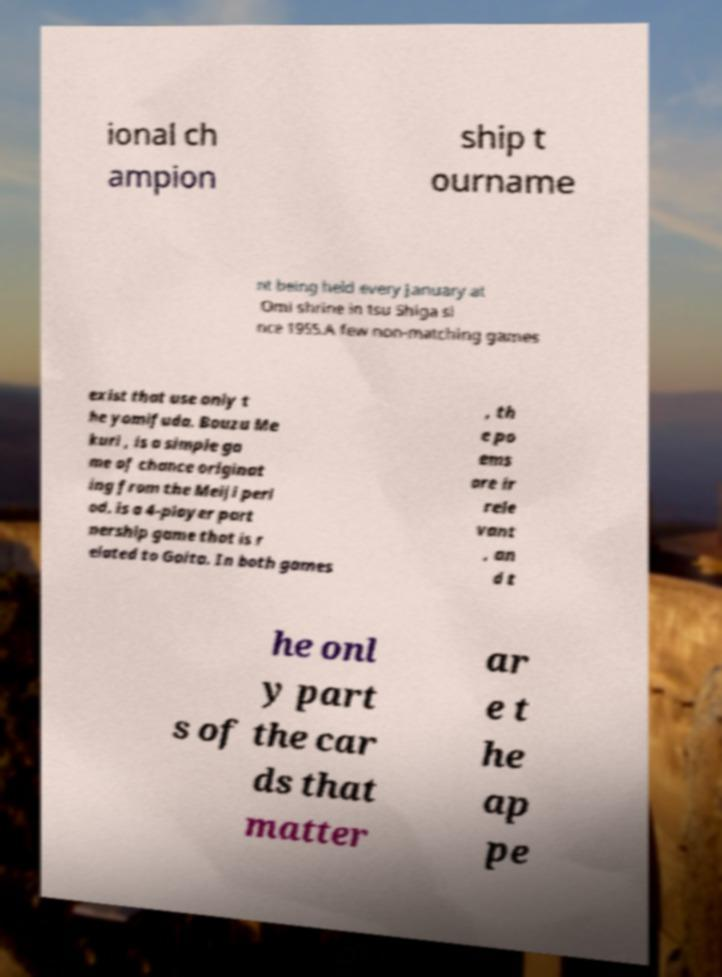Please read and relay the text visible in this image. What does it say? ional ch ampion ship t ourname nt being held every January at Omi shrine in tsu Shiga si nce 1955.A few non-matching games exist that use only t he yomifuda. Bouzu Me kuri , is a simple ga me of chance originat ing from the Meiji peri od. is a 4-player part nership game that is r elated to Goita. In both games , th e po ems are ir rele vant , an d t he onl y part s of the car ds that matter ar e t he ap pe 